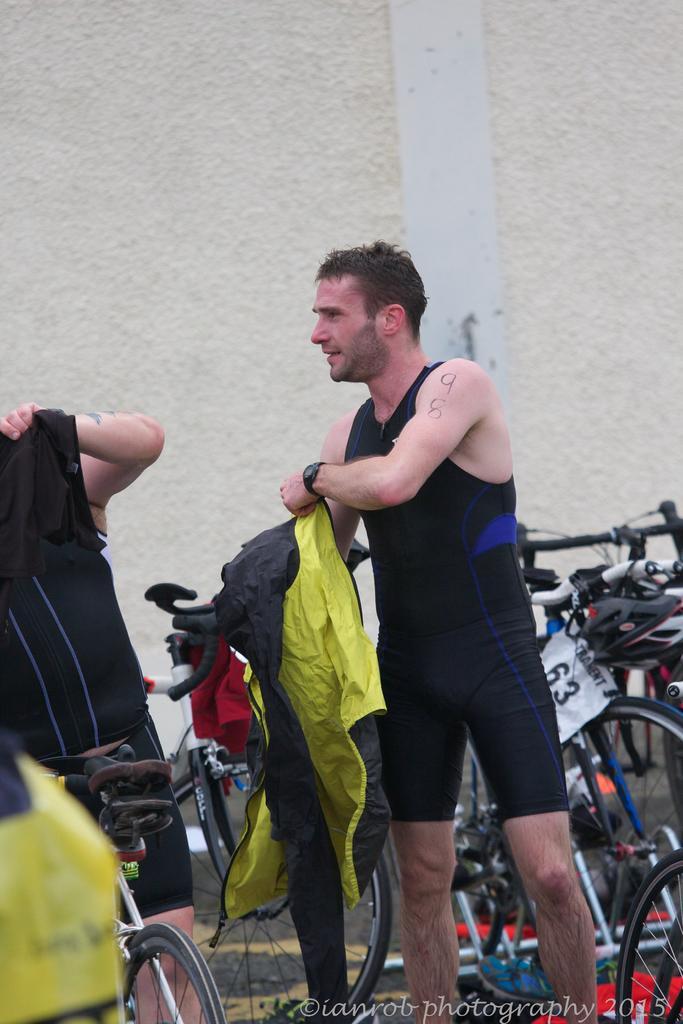In one or two sentences, can you explain what this image depicts? In this picture we can see there are two people standing and a person is holding a jacket. Behind the people there are bicycles and a wall. On the image there is a watermark. 